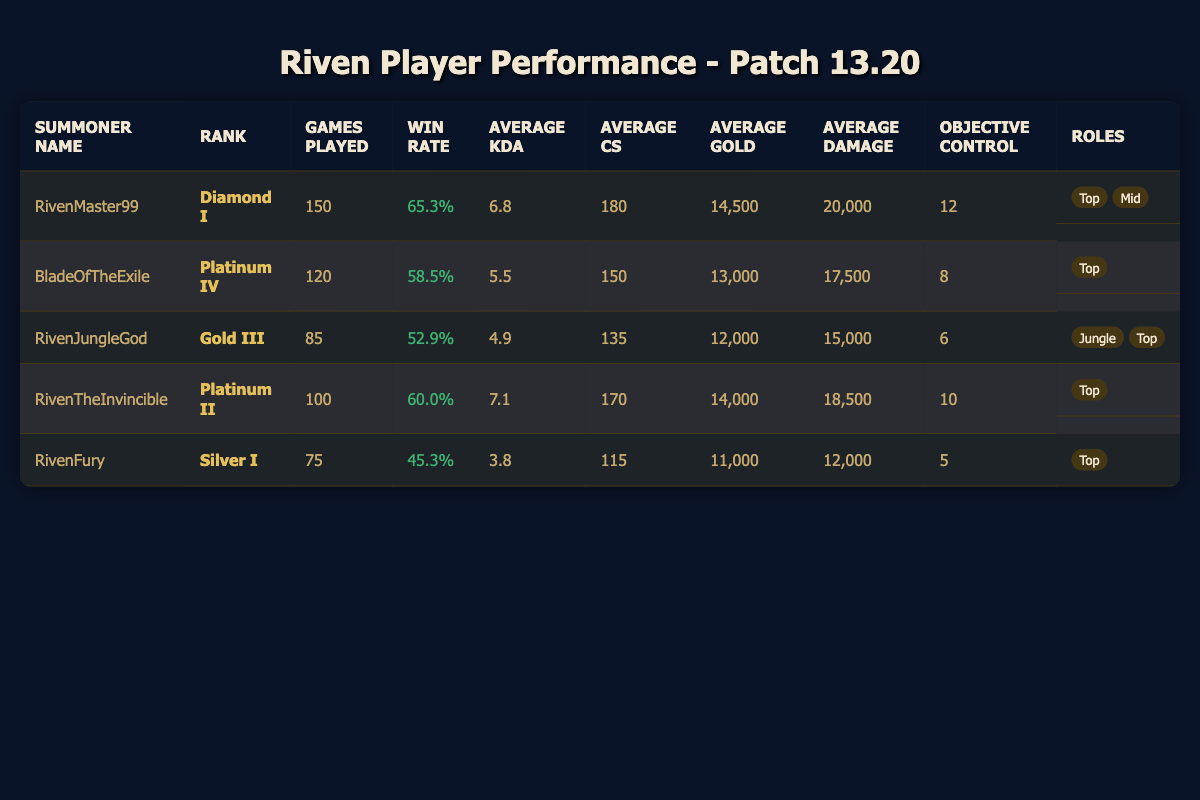What is the win rate of RivenMaster99? According to the table, RivenMaster99 has a win rate listed as 65.3%.
Answer: 65.3% How many games did RivenFury play? The table states that RivenFury played 75 games.
Answer: 75 Which player has the highest average KDA? By comparing the average KDA values, RivenMaster99 has the highest KDA at 6.8.
Answer: RivenMaster99 What is the average gold earned by players who played more than 100 games? The players with more than 100 games are RivenMaster99 (14,500), BladeOfTheExile (13,000), and RivenTheInvincible (14,000). Adding these and dividing by 3 gives (14,500 + 13,000 + 14,000) / 3 = 13,833.33.
Answer: 13,833.33 Is RivenJungleGod’s win rate above or below 50%? The win rate for RivenJungleGod is 52.9%, which is above 50%.
Answer: Above How many different roles does RivenMaster99 play? The table indicates RivenMaster99 plays two roles: Top and Mid.
Answer: 2 What is the total objective control for all players combined? The objective control values are 12, 8, 6, 10, and 5. Summing these gives 12 + 8 + 6 + 10 + 5 = 41.
Answer: 41 Which player has the lowest average damage per game? From the listed average damage per game, RivenFury has the lowest at 12,000.
Answer: RivenFury What is the difference in average CS between RivenMaster99 and RivenFury? RivenMaster99 has an average CS of 180, while RivenFury has an average of 115. The difference is 180 - 115 = 65.
Answer: 65 Are there any players with a win rate of 60% or higher? Yes, RivenMaster99 (65.3%) and RivenTheInvincible (60.0%) both have win rates of 60% or higher.
Answer: Yes What rank does RivenTheInvincible hold? The table indicates that RivenTheInvincible is ranked Platinum II.
Answer: Platinum II Which Riven player has the highest games played? RivenMaster99 has the highest games played at 150.
Answer: RivenMaster99 What is the average gold earned by the Riven players listed? To find the average gold, we sum the gold values (14,500 + 13,000 + 12,000 + 14,000 + 11,000 = 64,500) and divide by the number of players (5). The average is 64,500 / 5 = 12,900.
Answer: 12,900 Is it true that all players play as Riven in the Top role? No, not all players play as Riven only in the Top role; for example, RivenJungleGod also plays Jungle and RivenMaster99 plays Mid.
Answer: No What rank does the player with the second highest average damage per game have? RivenTheInvincible has the second highest average damage per game at 18,500 and is ranked Platinum II.
Answer: Platinum II 